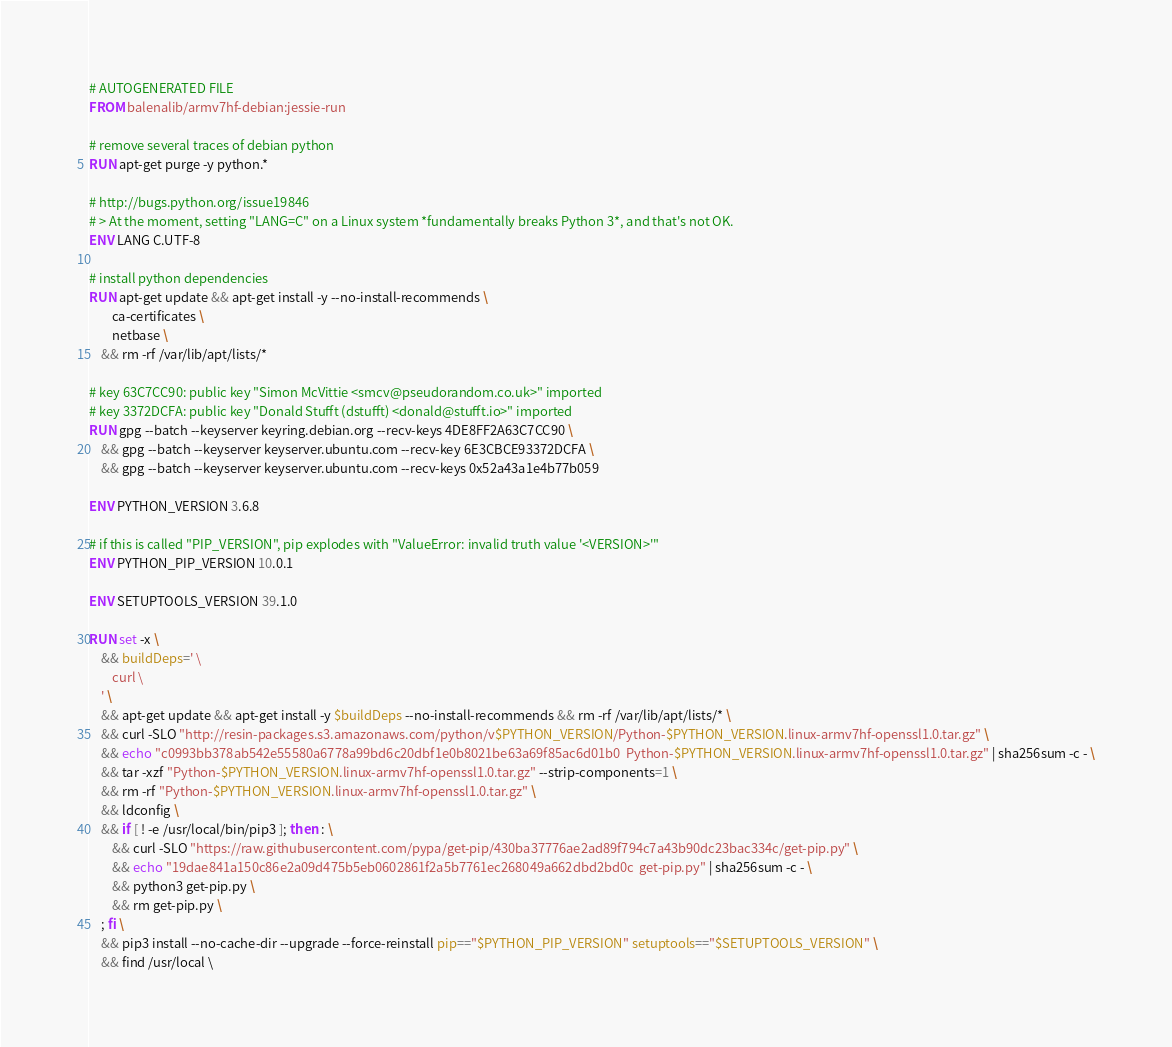<code> <loc_0><loc_0><loc_500><loc_500><_Dockerfile_># AUTOGENERATED FILE
FROM balenalib/armv7hf-debian:jessie-run

# remove several traces of debian python
RUN apt-get purge -y python.*

# http://bugs.python.org/issue19846
# > At the moment, setting "LANG=C" on a Linux system *fundamentally breaks Python 3*, and that's not OK.
ENV LANG C.UTF-8

# install python dependencies
RUN apt-get update && apt-get install -y --no-install-recommends \
		ca-certificates \
		netbase \
	&& rm -rf /var/lib/apt/lists/*

# key 63C7CC90: public key "Simon McVittie <smcv@pseudorandom.co.uk>" imported
# key 3372DCFA: public key "Donald Stufft (dstufft) <donald@stufft.io>" imported
RUN gpg --batch --keyserver keyring.debian.org --recv-keys 4DE8FF2A63C7CC90 \
	&& gpg --batch --keyserver keyserver.ubuntu.com --recv-key 6E3CBCE93372DCFA \
	&& gpg --batch --keyserver keyserver.ubuntu.com --recv-keys 0x52a43a1e4b77b059

ENV PYTHON_VERSION 3.6.8

# if this is called "PIP_VERSION", pip explodes with "ValueError: invalid truth value '<VERSION>'"
ENV PYTHON_PIP_VERSION 10.0.1

ENV SETUPTOOLS_VERSION 39.1.0

RUN set -x \
	&& buildDeps=' \
		curl \
	' \
	&& apt-get update && apt-get install -y $buildDeps --no-install-recommends && rm -rf /var/lib/apt/lists/* \
	&& curl -SLO "http://resin-packages.s3.amazonaws.com/python/v$PYTHON_VERSION/Python-$PYTHON_VERSION.linux-armv7hf-openssl1.0.tar.gz" \
	&& echo "c0993bb378ab542e55580a6778a99bd6c20dbf1e0b8021be63a69f85ac6d01b0  Python-$PYTHON_VERSION.linux-armv7hf-openssl1.0.tar.gz" | sha256sum -c - \
	&& tar -xzf "Python-$PYTHON_VERSION.linux-armv7hf-openssl1.0.tar.gz" --strip-components=1 \
	&& rm -rf "Python-$PYTHON_VERSION.linux-armv7hf-openssl1.0.tar.gz" \
	&& ldconfig \
	&& if [ ! -e /usr/local/bin/pip3 ]; then : \
		&& curl -SLO "https://raw.githubusercontent.com/pypa/get-pip/430ba37776ae2ad89f794c7a43b90dc23bac334c/get-pip.py" \
		&& echo "19dae841a150c86e2a09d475b5eb0602861f2a5b7761ec268049a662dbd2bd0c  get-pip.py" | sha256sum -c - \
		&& python3 get-pip.py \
		&& rm get-pip.py \
	; fi \
	&& pip3 install --no-cache-dir --upgrade --force-reinstall pip=="$PYTHON_PIP_VERSION" setuptools=="$SETUPTOOLS_VERSION" \
	&& find /usr/local \</code> 